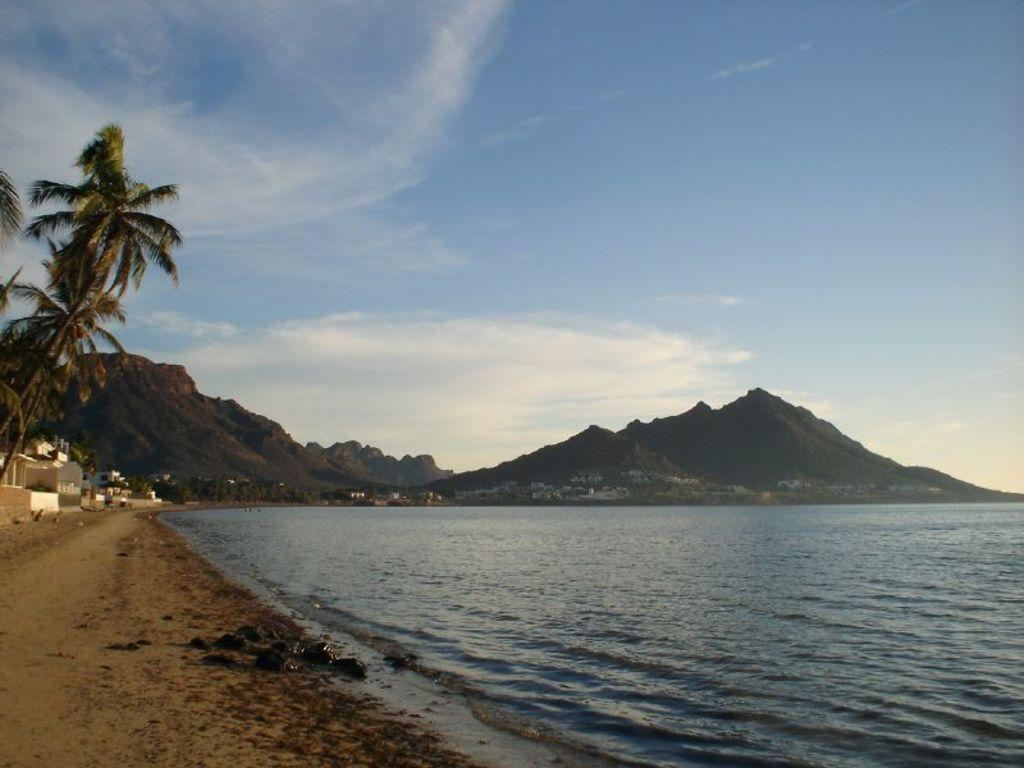What is the main feature of the image? There is water in the image. What can be seen on the right side of the image? There are houses and trees on the right side of the image. What is visible in the background of the image? There are mountains in the background of the image. How would you describe the sky in the image? The sky is blue and cloudy. What type of condition is the chess game in the image? There is no chess game present in the image. Is there a cap visible on any of the people in the image? There are no people visible in the image, so it is impossible to determine if anyone is wearing a cap. 